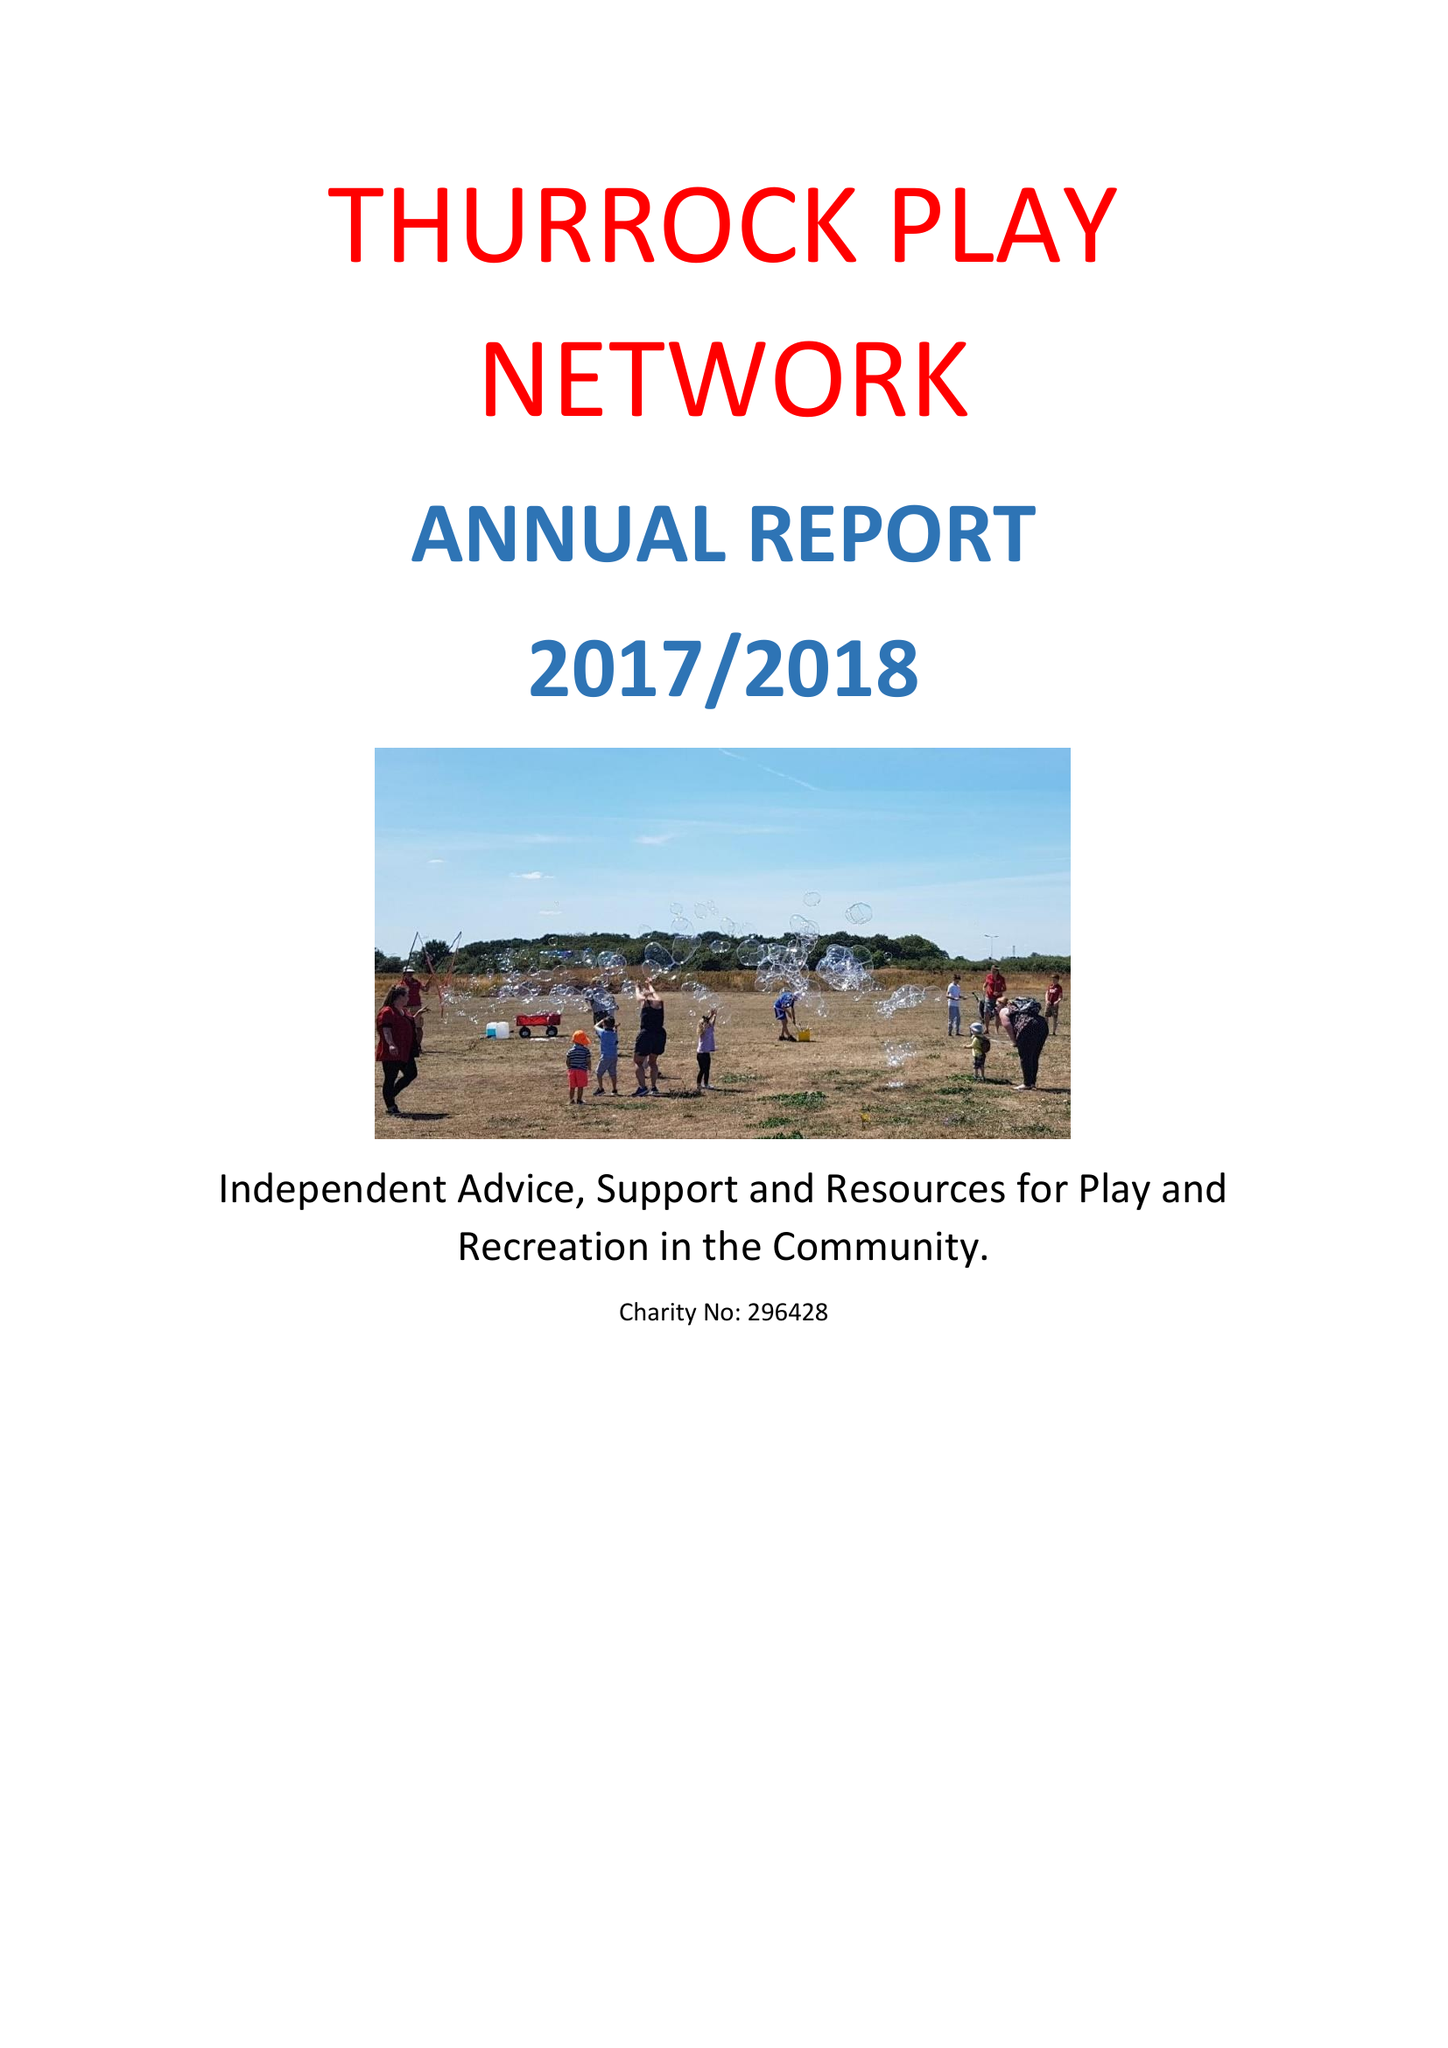What is the value for the spending_annually_in_british_pounds?
Answer the question using a single word or phrase. 73140.00 